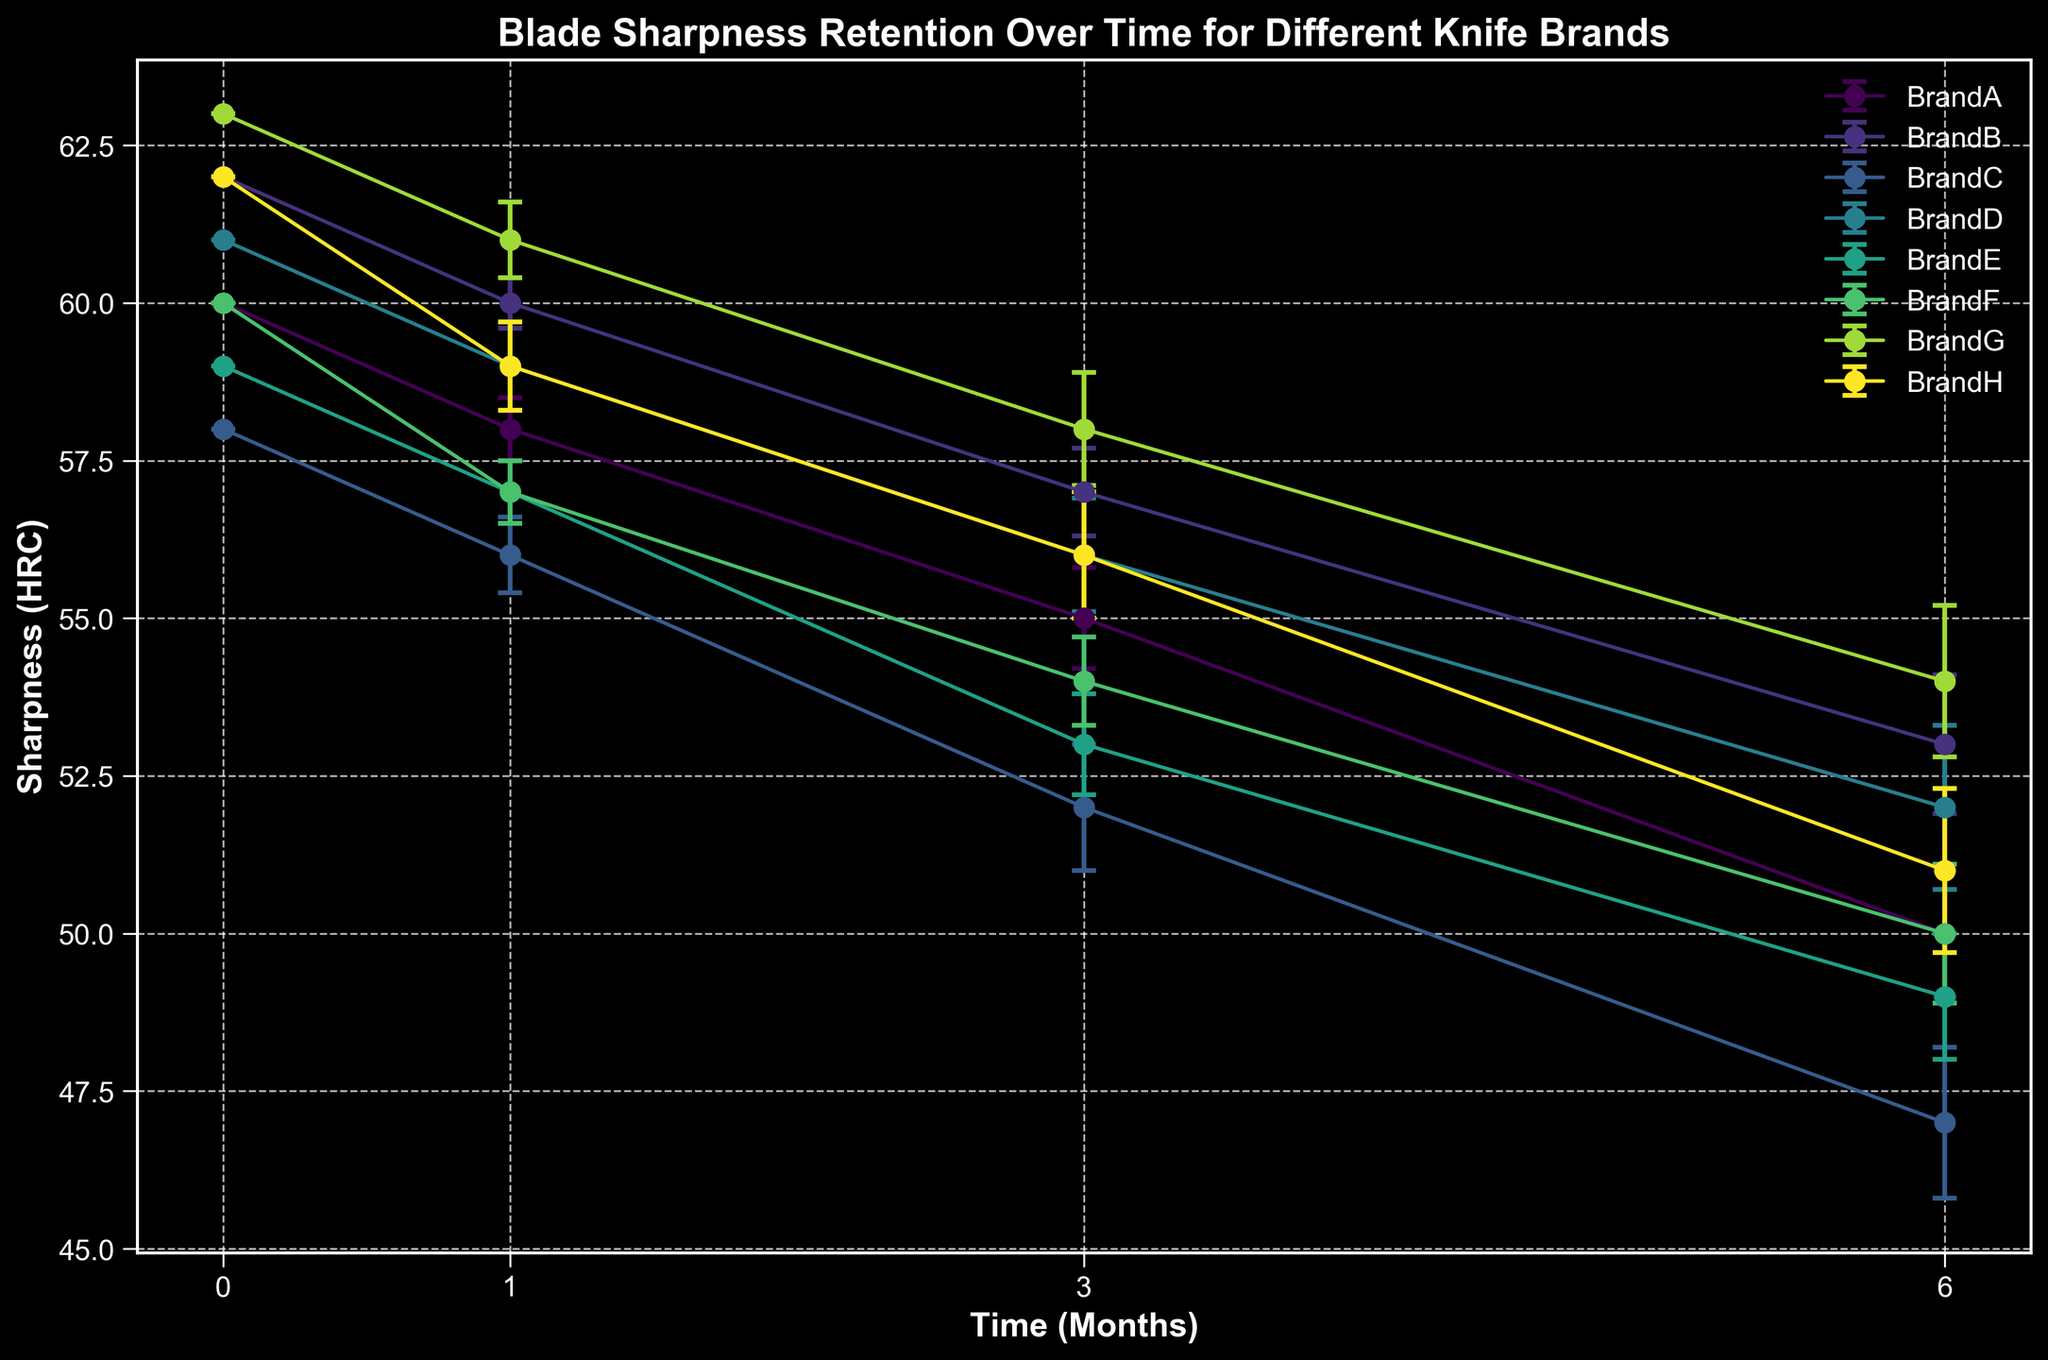What's the initial sharpness for BrandD? BrandD is depicted by a line in the chart. We find the value at the 0-month mark (initial sharpness), which is at the start of the line corresponding to BrandD.
Answer: 61 Between BrandA and BrandG, which knife brand retains more sharpness after 3 months? Locate the sharpness values for both brands at the 3-month mark. BrandA’s sharpness after 3 months is at 55 HRC, while BrandG's is at 58 HRC. BrandG retains more sharpness.
Answer: BrandG What is the difference in sharpness after 6 months between BrandC and BrandH? At the 6-month data point, BrandC has a sharpness of 47 HRC, and BrandH has a sharpness of 51 HRC. The difference is calculated as 51 - 47.
Answer: 4 Which brand has the smallest standard deviation after 1 month? Observe the error bars for each brand at the 1-month mark. The shorter the error bar, the smaller the standard deviation. BrandB has the smallest standard deviation.
Answer: BrandB How many brands end up with sharpness below 52 HRC after 6 months? Look at the values at the 6-month point for each brand. BrandA (50), BrandC (47), BrandE (49), BrandF (50), and BrandH (51) are below 52 HRC. That's five brands.
Answer: 5 Which brand shows the greatest decline in sharpness from the initial to 6 months? Calculate the decline for each brand by subtracting the sharpness value at 6 months from the initial sharpness value. Choose the largest difference.
Answer: BrandC What is the average sharpness of all brands after 3 months? Add the sharpness values of all brands at the 3-month mark and divide by the number of brands. The sum is (55 + 57 + 52 + 56 + 53 + 54 + 58 + 56 = 441). Divide by 8 (number of brands).
Answer: 55.1 Which brand has the highest initial sharpness? Locate the initial sharpness values (time 0) for all brands. The brand with the highest value is BrandG with 63 HRC.
Answer: BrandG 